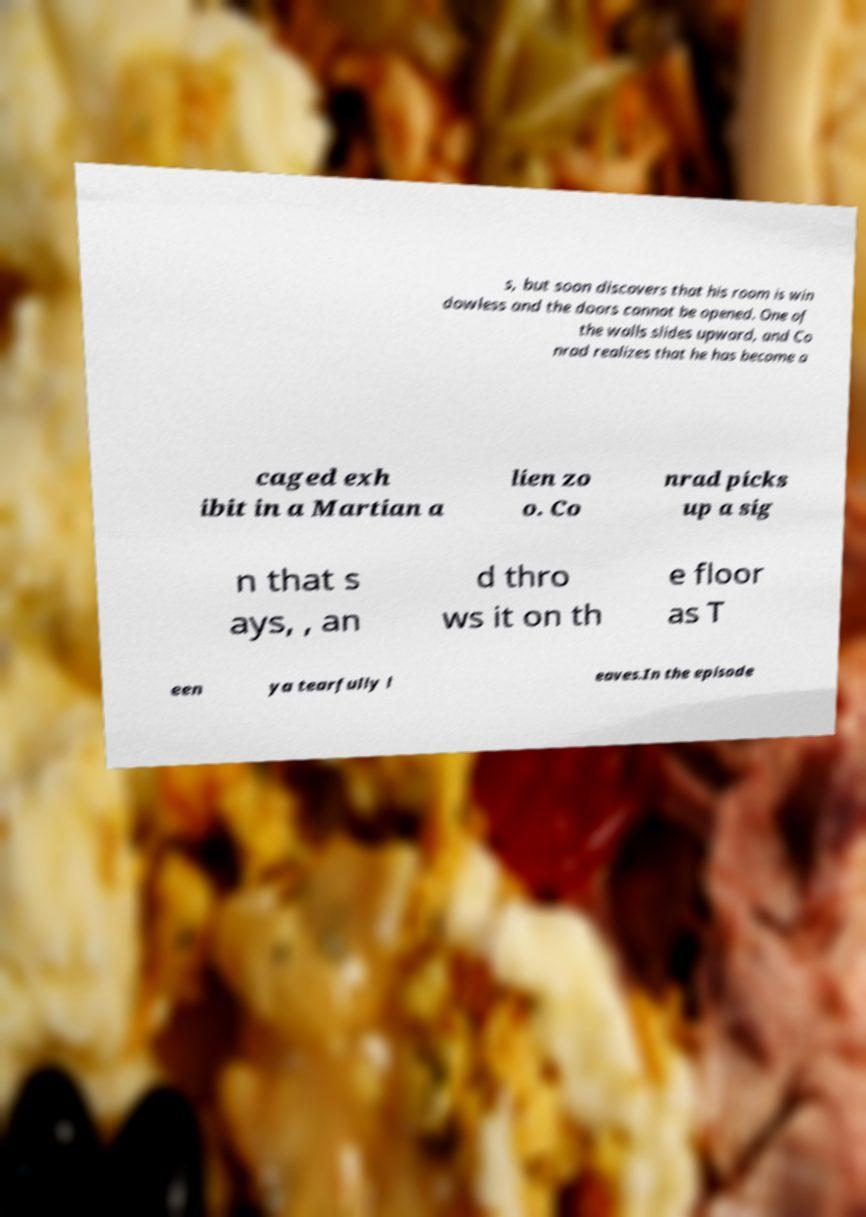Please identify and transcribe the text found in this image. s, but soon discovers that his room is win dowless and the doors cannot be opened. One of the walls slides upward, and Co nrad realizes that he has become a caged exh ibit in a Martian a lien zo o. Co nrad picks up a sig n that s ays, , an d thro ws it on th e floor as T een ya tearfully l eaves.In the episode 